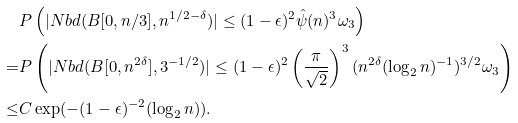<formula> <loc_0><loc_0><loc_500><loc_500>& P \left ( | N b d ( B [ 0 , n / 3 ] , n ^ { 1 / 2 - \delta } ) | \leq ( 1 - \epsilon ) ^ { 2 } \hat { \psi } ( n ) ^ { 3 } \omega _ { 3 } \right ) \\ = & P \left ( | N b d ( B [ 0 , n ^ { 2 \delta } ] , 3 ^ { - 1 / 2 } ) | \leq ( 1 - \epsilon ) ^ { 2 } \left ( \frac { \pi } { \sqrt { 2 } } \right ) ^ { 3 } ( n ^ { 2 \delta } ( \log _ { 2 } n ) ^ { - 1 } ) ^ { 3 / 2 } \omega _ { 3 } \right ) \\ \leq & C \exp ( - ( 1 - \epsilon ) ^ { - 2 } ( \log _ { 2 } n ) ) .</formula> 